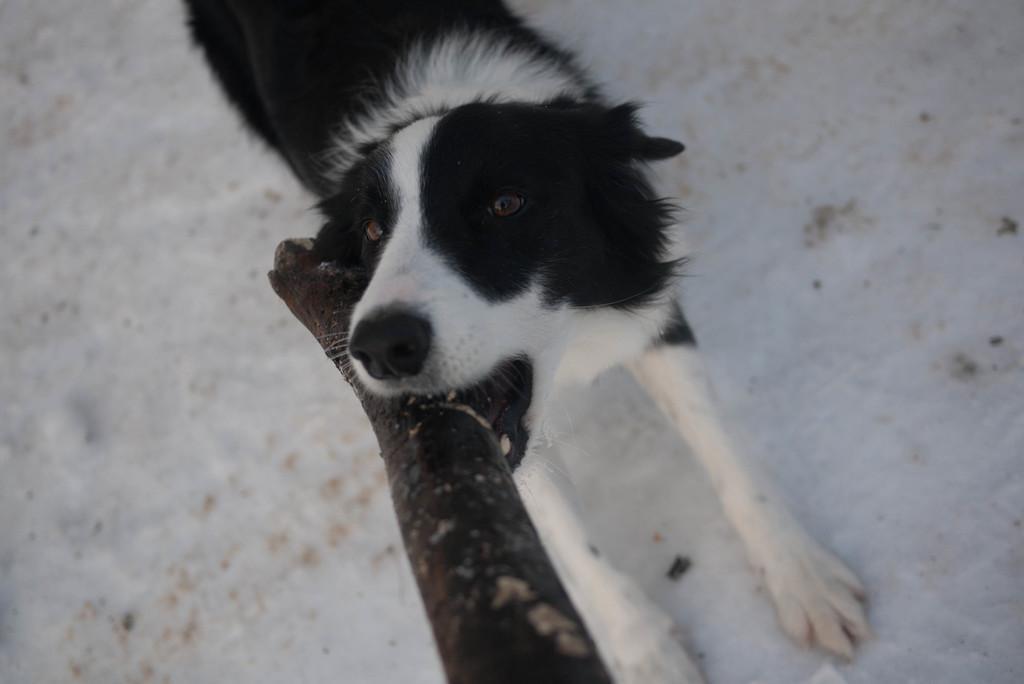Describe this image in one or two sentences. In this picture we can observe a dog which is in white and black color. This dog is holding a wooden stick in its mouth. This dog is standing on the floor which is in white color. 